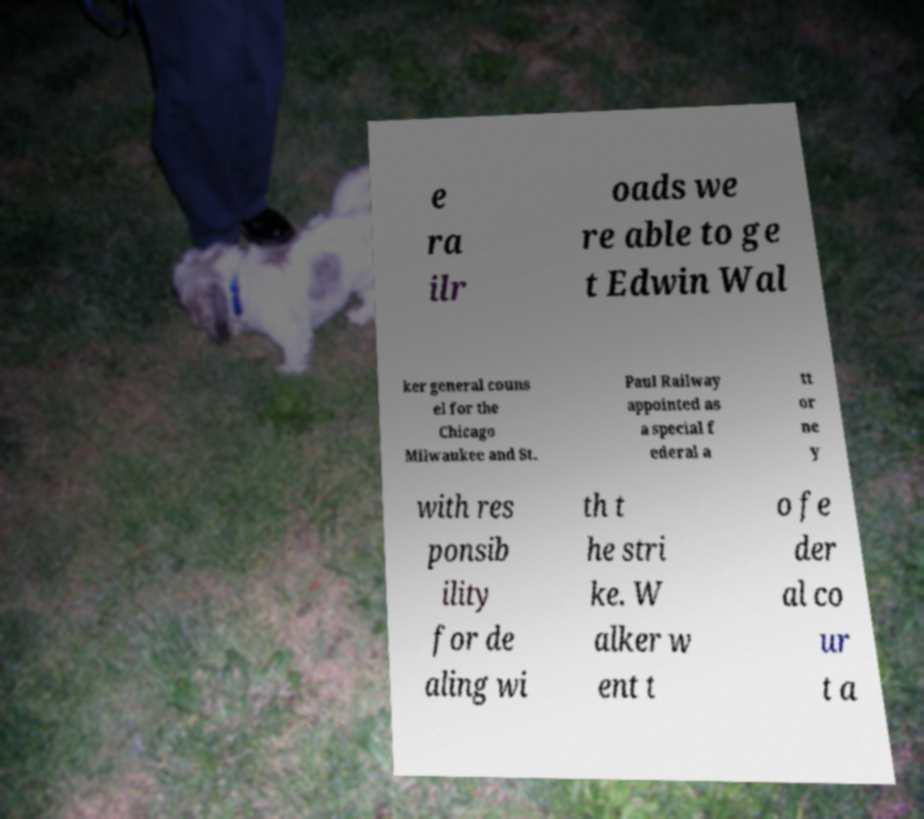For documentation purposes, I need the text within this image transcribed. Could you provide that? e ra ilr oads we re able to ge t Edwin Wal ker general couns el for the Chicago Milwaukee and St. Paul Railway appointed as a special f ederal a tt or ne y with res ponsib ility for de aling wi th t he stri ke. W alker w ent t o fe der al co ur t a 